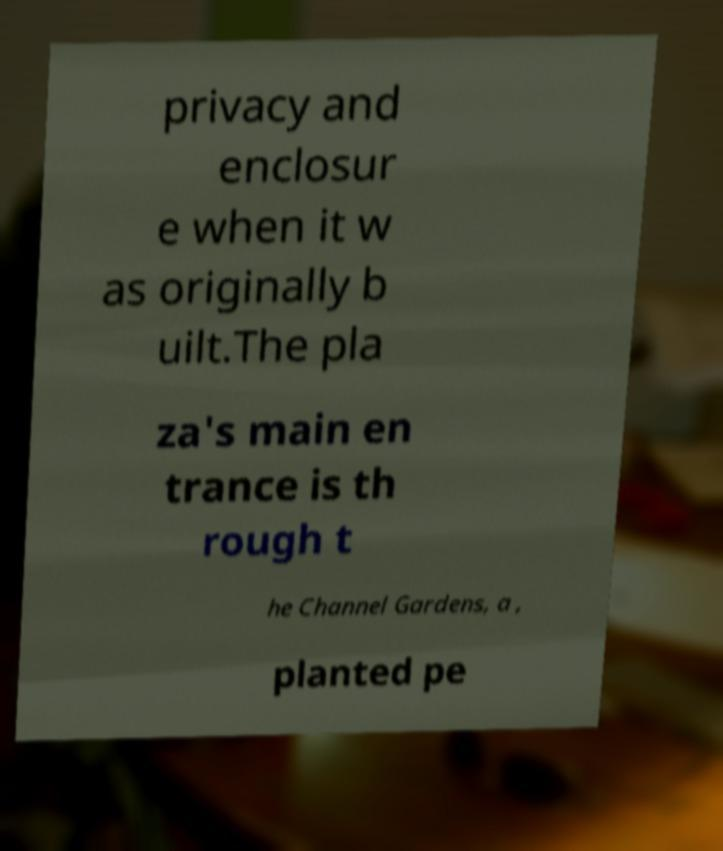I need the written content from this picture converted into text. Can you do that? privacy and enclosur e when it w as originally b uilt.The pla za's main en trance is th rough t he Channel Gardens, a , planted pe 